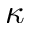<formula> <loc_0><loc_0><loc_500><loc_500>\kappa</formula> 